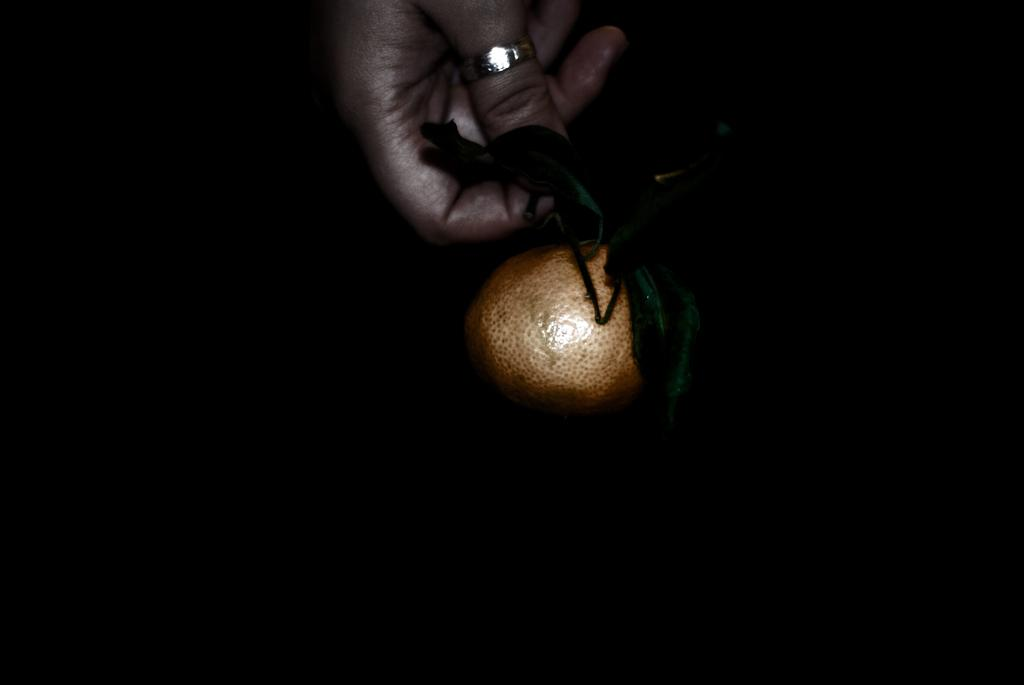What part of a person is visible in the image? There is a hand of a person in the image. What is the hand holding? The hand is holding an orange-colored object. Are there any accessories visible on the hand? Yes, there is a ring on one of the fingers. How would you describe the overall appearance of the image? The image has a dark appearance. What type of egg is being crushed by the hand in the image? There is no egg present in the image; the hand is holding an orange-colored object. Is there a boy visible in the image? There is no boy visible in the image; only a hand is present. 